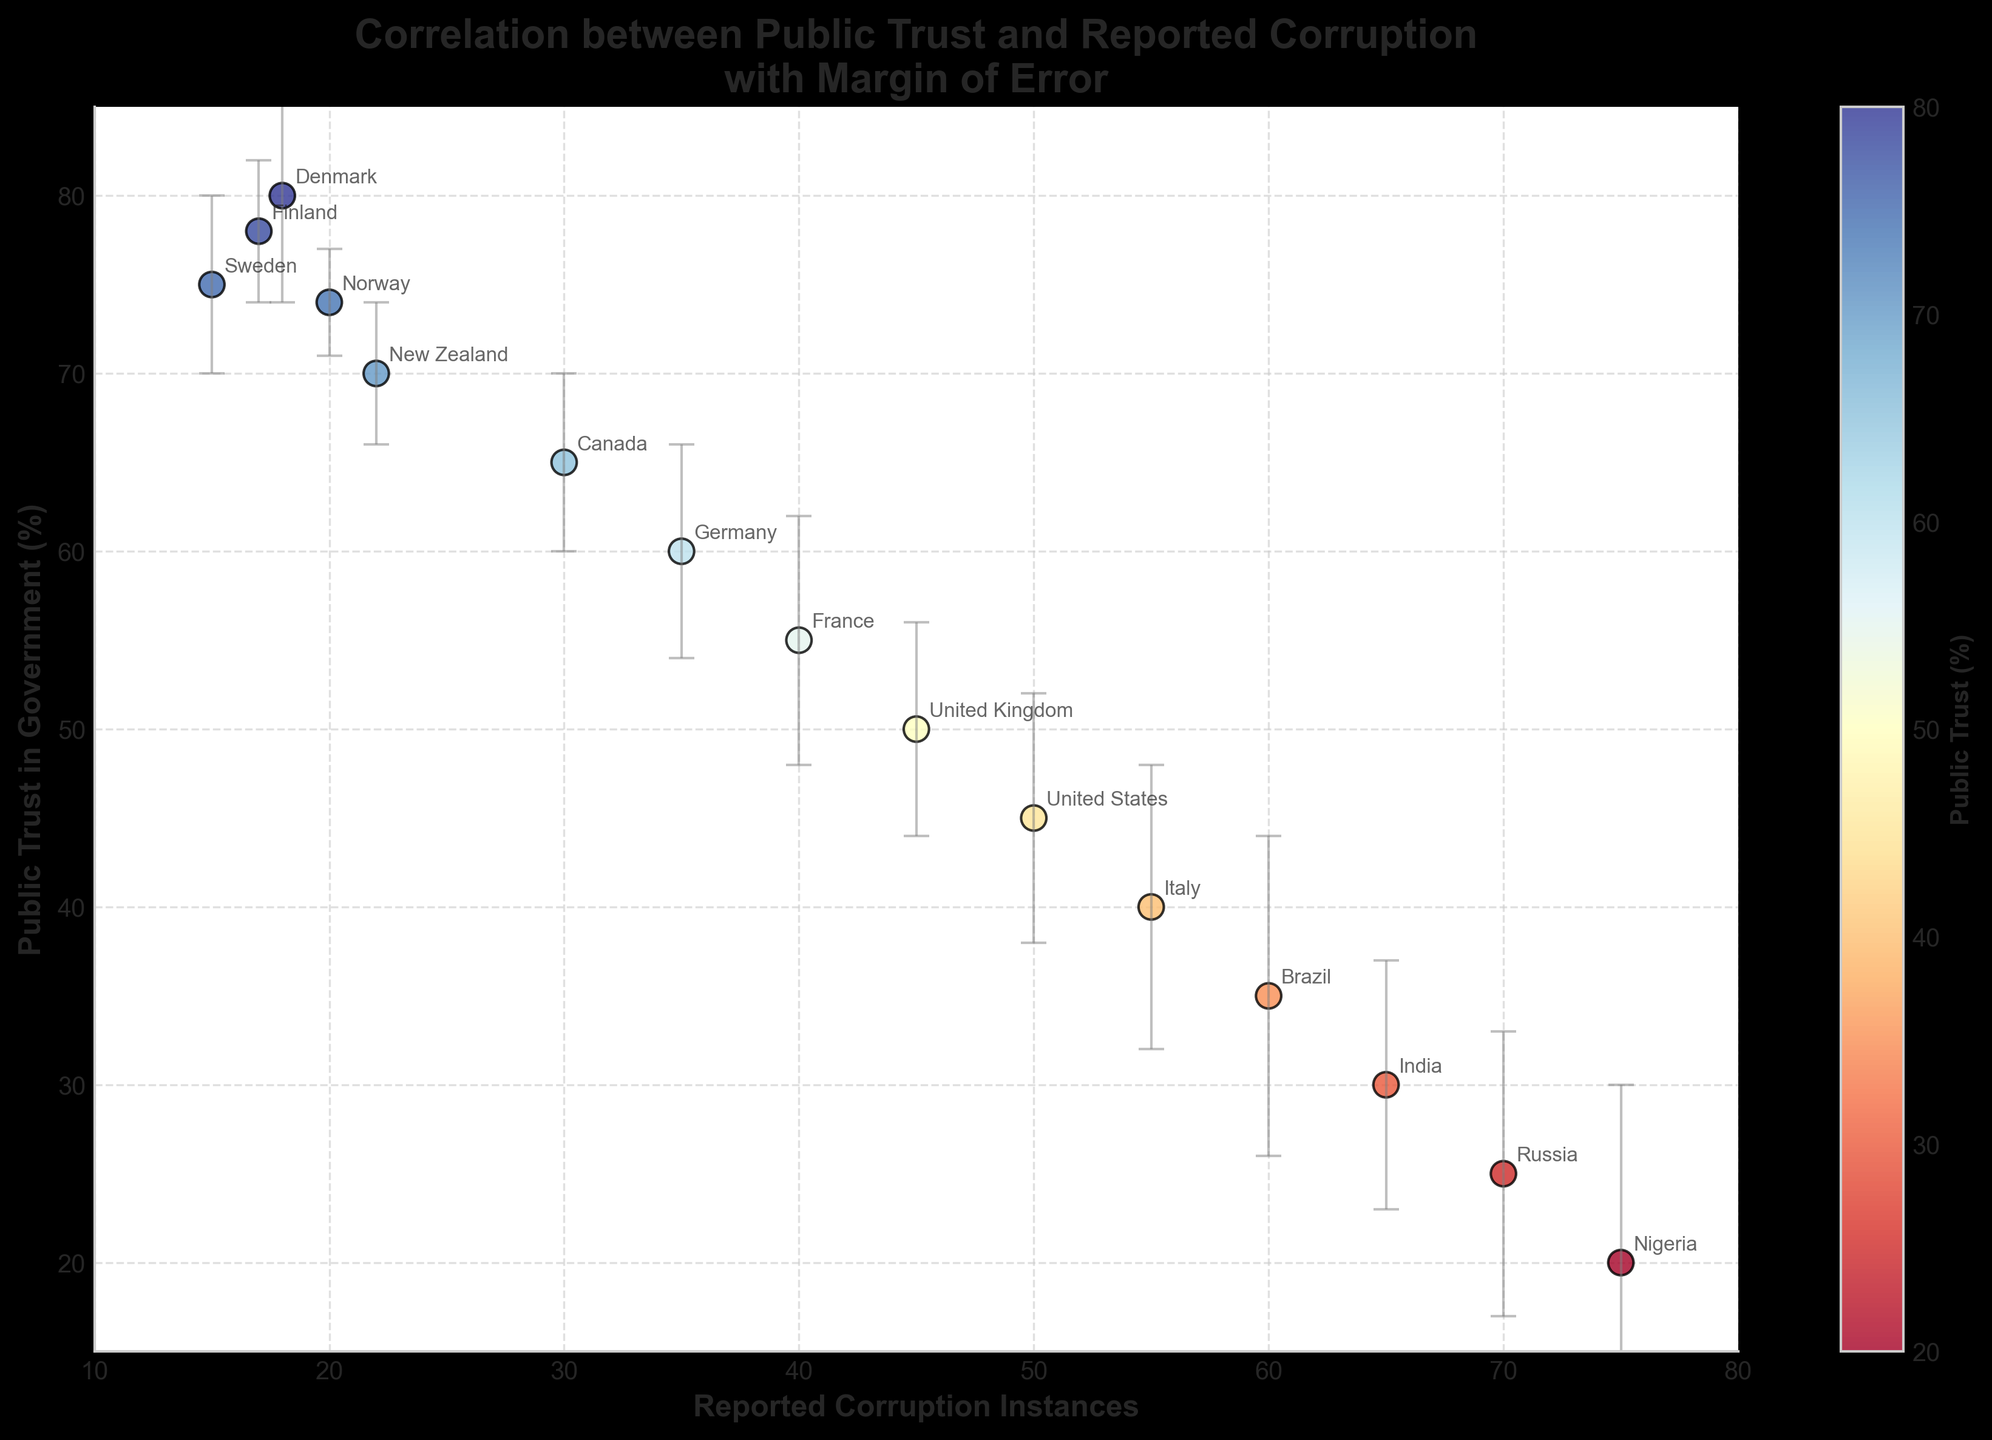What is the title of the plot? The title of the plot is displayed at the top center of the figure. It reads "Correlation between Public Trust and Reported Corruption\nwith Margin of Error".
Answer: "Correlation between Public Trust and Reported Corruption\nwith Margin of Error" Which country has the highest public trust in government according to the plot? By looking at the vertical axis (Public Trust in Government) and identifying the highest value point, we see that Denmark has the highest public trust level at 80%.
Answer: Denmark What is the range of reported corruption instances shown on the horizontal axis? The range on the horizontal axis can be observed from the beginning to the end of the axis, showing values from 10 to 80.
Answer: 10 to 80 Which country has the highest margin of error? The margin of error is indicated by the error bars; we look for the longest error bar. Nigeria has the longest error bar with a margin of error of 10.
Answer: Nigeria Can you rank Sweden, Norway, and Finland based on their public trust in government from highest to lowest? By referring to the vertical axis (Public Trust in Government), Finland has the highest trust (78%), followed by Sweden (75%), and then Norway (74%).
Answer: Finland, Sweden, Norway How does the public trust in government in Canada compare to the United States? By locating both Canada and United States on the vertical axis and comparing their positions, Canada has a public trust level of 65%, which is higher than the United States at 45%.
Answer: Canada has higher public trust than the United States What is the difference in reported corruption instances between France and Brazil? By locating France and Brazil on the horizontal axis (Reported Corruption Instances), France is at 40 instances and Brazil at 60 instances. The difference is 60 - 40 = 20 instances.
Answer: 20 instances Which countries fall within a reported corruption instance range of 50 to 70? By examining the horizontal axis and identifying the countries within the 50 to 70 instance range, we find the United States (50), Italy (55), Brazil (60), and India (65).
Answer: United States, Italy, Brazil, India What overall trend can be inferred about the relationship between public trust in government and reported instances of corruption? By observing the scatter plot pattern, a negative correlation is visible: as reported instances of corruption increase, public trust in government tends to decrease.
Answer: Negative correlation What is the average public trust in government for the countries with reported corruption instances above 60? The countries with reported corruption instances above 60 are Brazil (60), India (65), Russia (70), and Nigeria (75). Their public trust values are 35, 30, 25, and 20 respectively. The average is (35 + 30 + 25 + 20) / 4 = 27.5%.
Answer: 27.5% 